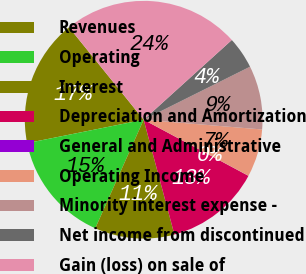Convert chart. <chart><loc_0><loc_0><loc_500><loc_500><pie_chart><fcel>Revenues<fcel>Operating<fcel>Interest<fcel>Depreciation and Amortization<fcel>General and Administrative<fcel>Operating Income<fcel>Minority interest expense -<fcel>Net income from discontinued<fcel>Gain (loss) on sale of<nl><fcel>17.34%<fcel>15.17%<fcel>10.84%<fcel>13.01%<fcel>0.01%<fcel>6.51%<fcel>8.67%<fcel>4.34%<fcel>24.11%<nl></chart> 